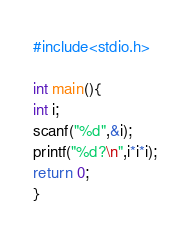Convert code to text. <code><loc_0><loc_0><loc_500><loc_500><_C_>#include<stdio.h>

int main(){
int i;
scanf("%d",&i);
printf("%d?\n",i*i*i);
return 0;
}</code> 